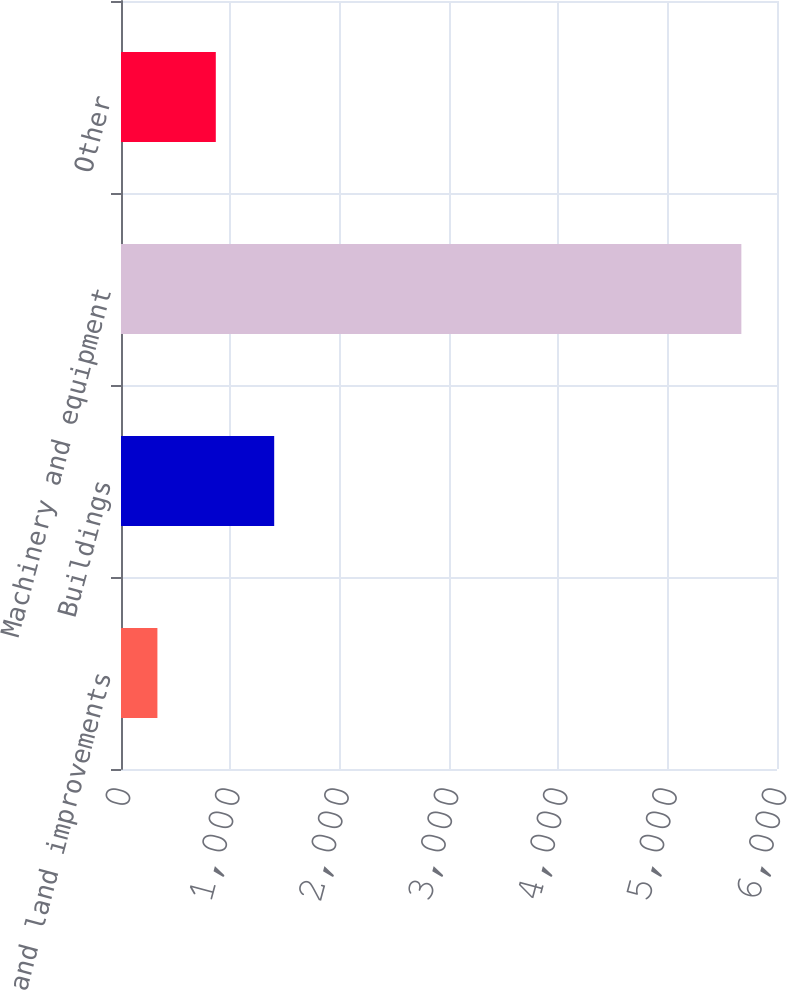Convert chart. <chart><loc_0><loc_0><loc_500><loc_500><bar_chart><fcel>Land and land improvements<fcel>Buildings<fcel>Machinery and equipment<fcel>Other<nl><fcel>333<fcel>1401.2<fcel>5674<fcel>867.1<nl></chart> 